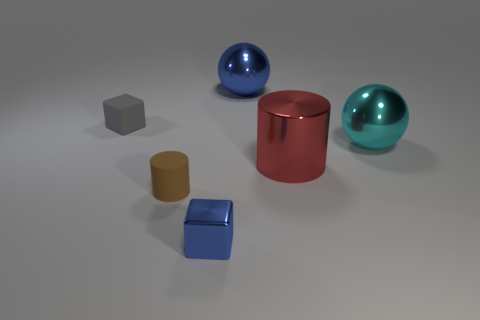Can you suggest what the purpose of arranging these objects might be? The arrangement of these objects might be for a display with educational intentions, such as a lesson on geometry, shapes, and volume. Alternatively, it could be an artistic composition meant to showcase contrasts in colors, textures, and forms. 